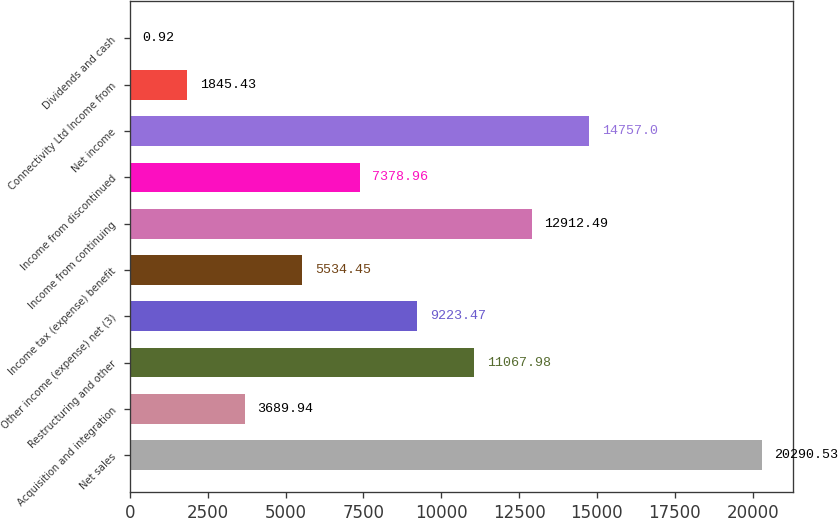<chart> <loc_0><loc_0><loc_500><loc_500><bar_chart><fcel>Net sales<fcel>Acquisition and integration<fcel>Restructuring and other<fcel>Other income (expense) net (3)<fcel>Income tax (expense) benefit<fcel>Income from continuing<fcel>Income from discontinued<fcel>Net income<fcel>Connectivity Ltd Income from<fcel>Dividends and cash<nl><fcel>20290.5<fcel>3689.94<fcel>11068<fcel>9223.47<fcel>5534.45<fcel>12912.5<fcel>7378.96<fcel>14757<fcel>1845.43<fcel>0.92<nl></chart> 